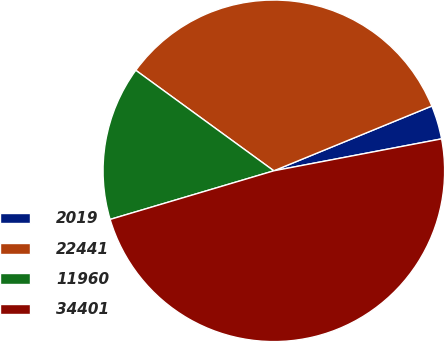Convert chart. <chart><loc_0><loc_0><loc_500><loc_500><pie_chart><fcel>2019<fcel>22441<fcel>11960<fcel>34401<nl><fcel>3.2%<fcel>33.79%<fcel>14.61%<fcel>48.4%<nl></chart> 